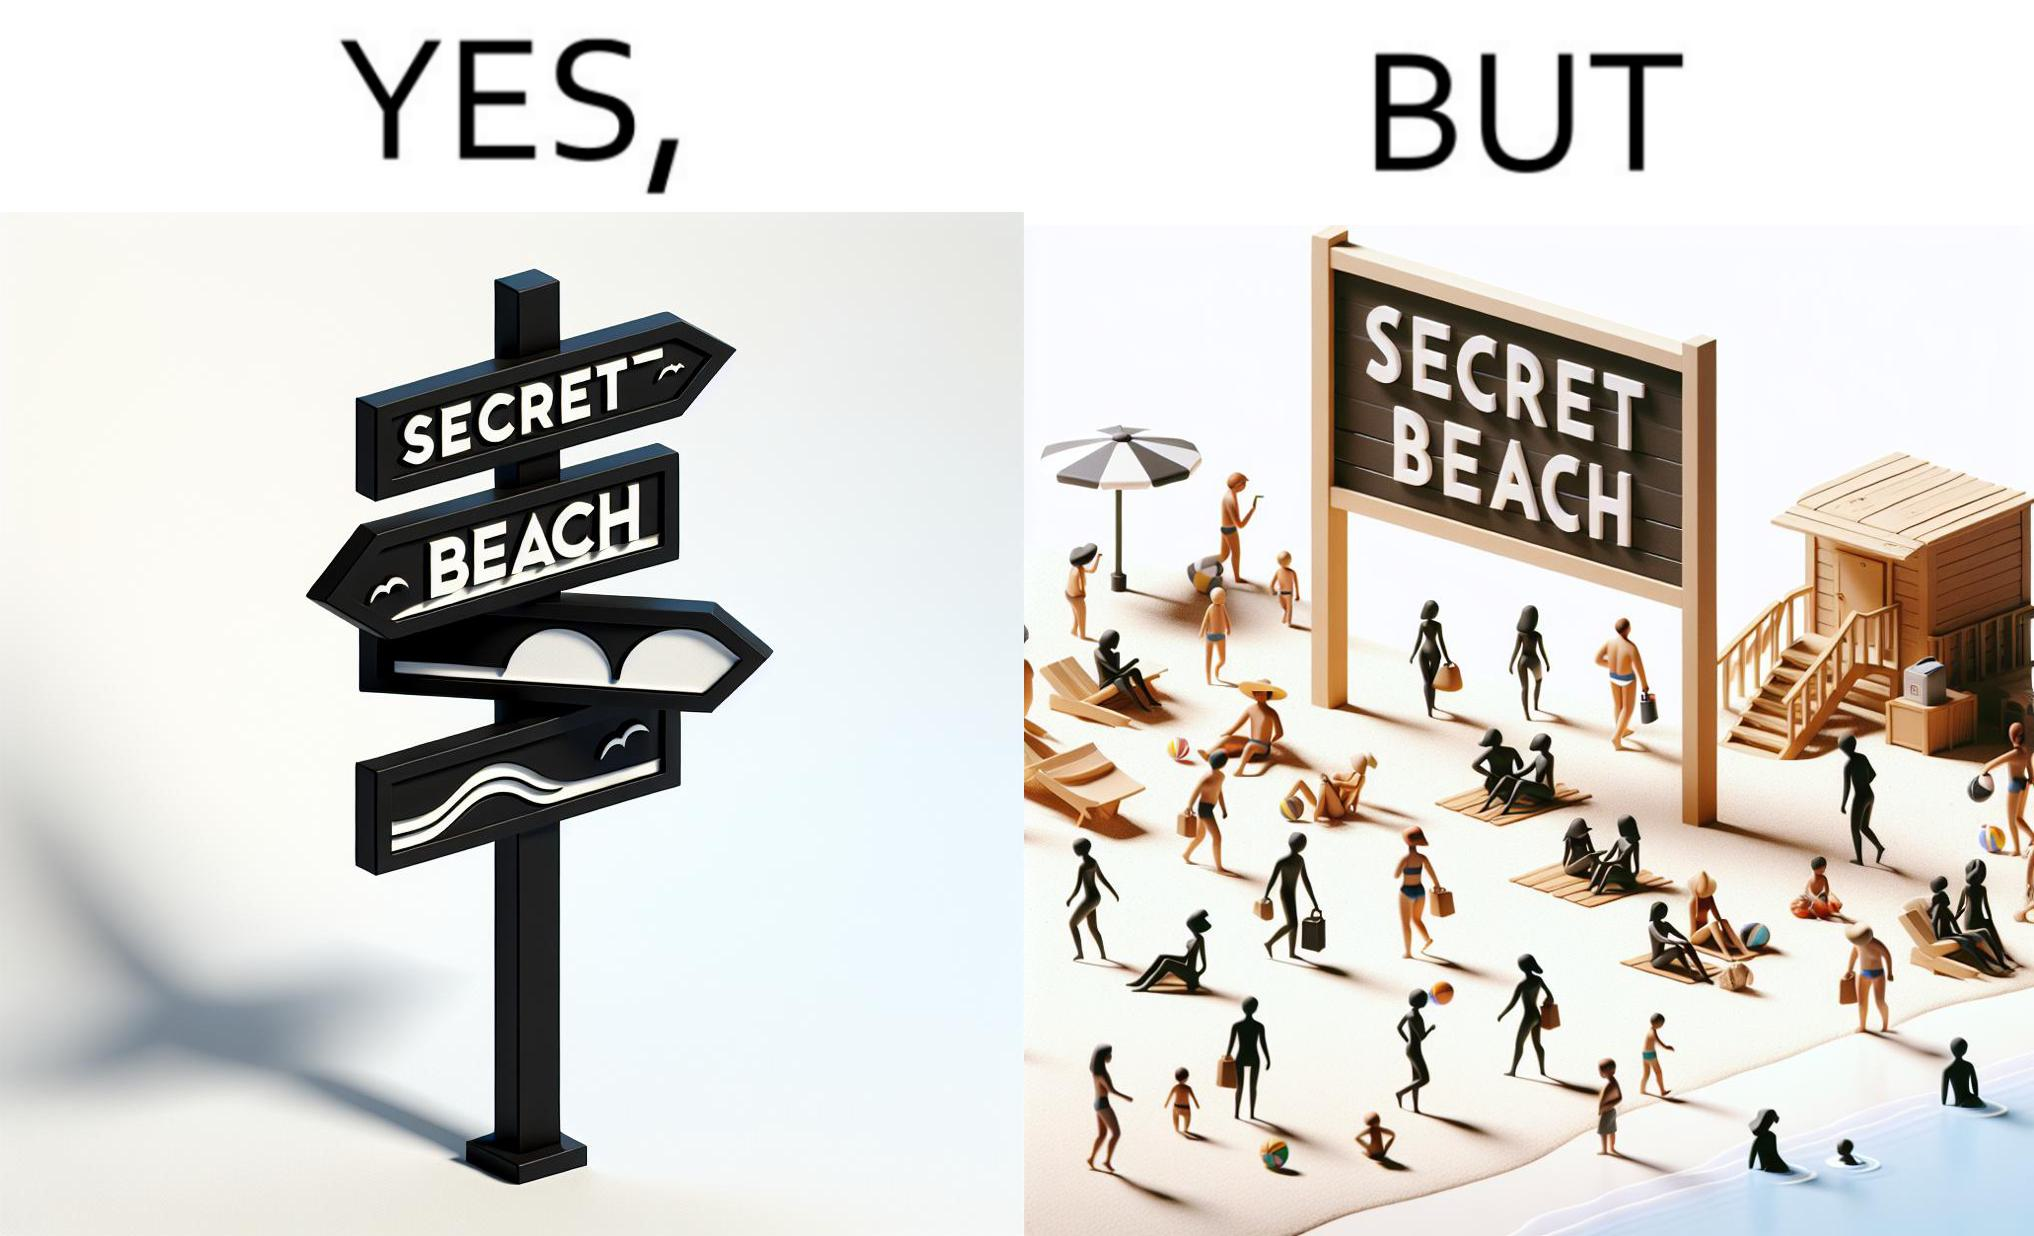Would you classify this image as satirical? Yes, this image is satirical. 